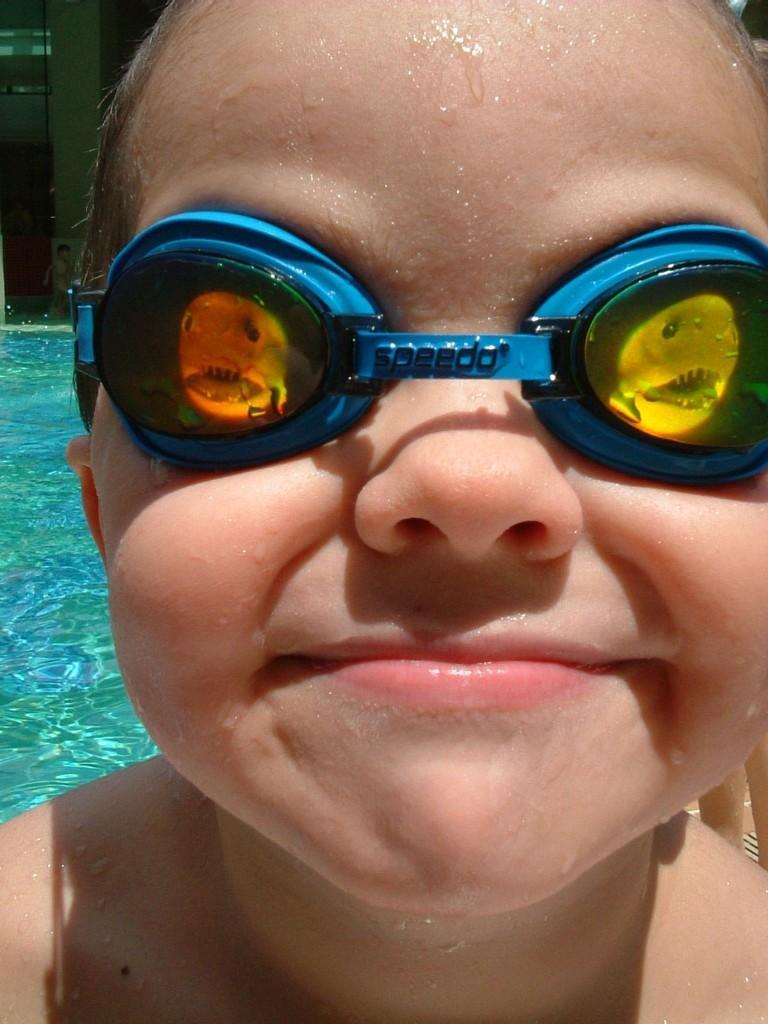In one or two sentences, can you explain what this image depicts? In this picture we can see a kid, the kid wore spectacles, in the background we can find water and we can see few more people. 